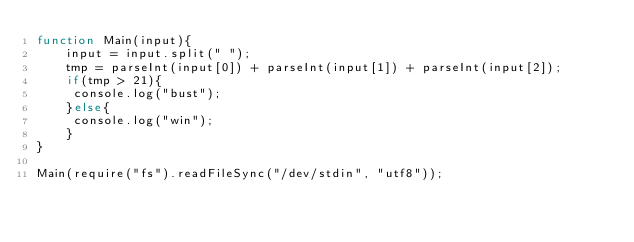Convert code to text. <code><loc_0><loc_0><loc_500><loc_500><_JavaScript_>function Main(input){
    input = input.split(" ");
    tmp = parseInt(input[0]) + parseInt(input[1]) + parseInt(input[2]);
    if(tmp > 21){
     console.log("bust");   
    }else{
     console.log("win");
    }
}
 
Main(require("fs").readFileSync("/dev/stdin", "utf8"));</code> 